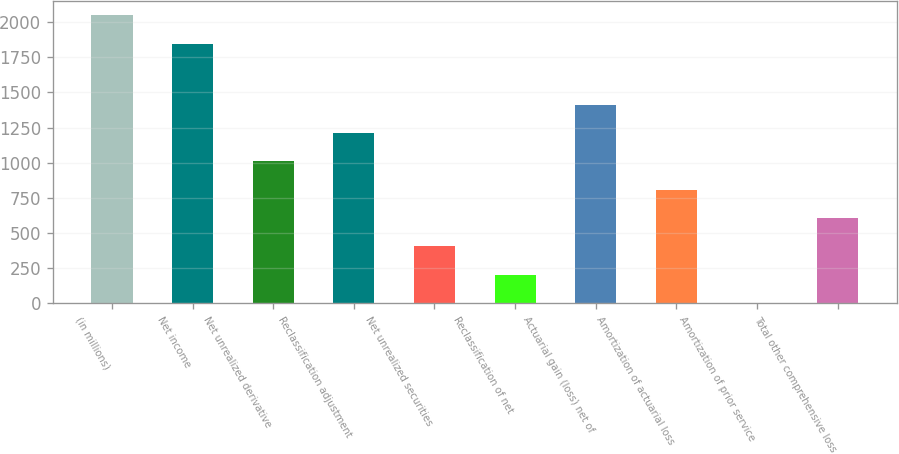Convert chart to OTSL. <chart><loc_0><loc_0><loc_500><loc_500><bar_chart><fcel>(in millions)<fcel>Net income<fcel>Net unrealized derivative<fcel>Reclassification adjustment<fcel>Net unrealized securities<fcel>Reclassification of net<fcel>Actuarial gain (loss) net of<fcel>Amortization of actuarial loss<fcel>Amortization of prior service<fcel>Total other comprehensive loss<nl><fcel>2048.2<fcel>1846.6<fcel>1009<fcel>1210.6<fcel>404.2<fcel>202.6<fcel>1412.2<fcel>807.4<fcel>1<fcel>605.8<nl></chart> 